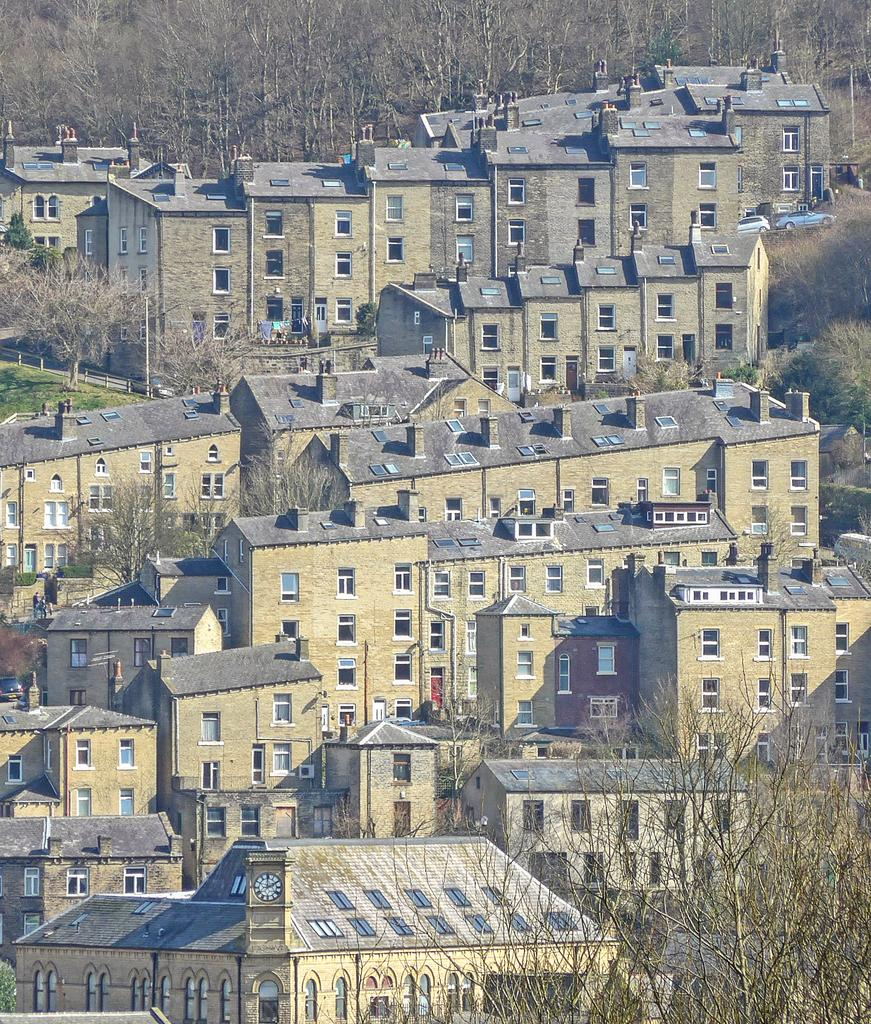What type of view is shown in the image? The image is a top view of a part of a city. What structures can be seen in the image? There are buildings visible in the image. What natural elements can be seen in the image? There are trees visible in the image. Can you tell me how many beggars are visible in the image? There is no mention of a beggar in the image, so it is not possible to determine how many are visible. 